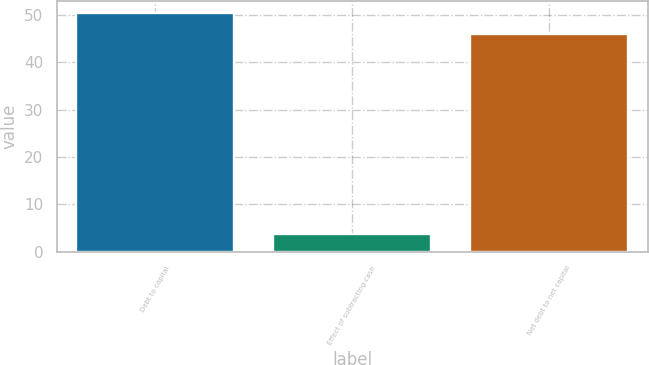Convert chart. <chart><loc_0><loc_0><loc_500><loc_500><bar_chart><fcel>Debt to capital<fcel>Effect of subtracting cash<fcel>Net debt to net capital<nl><fcel>50.49<fcel>3.8<fcel>45.9<nl></chart> 